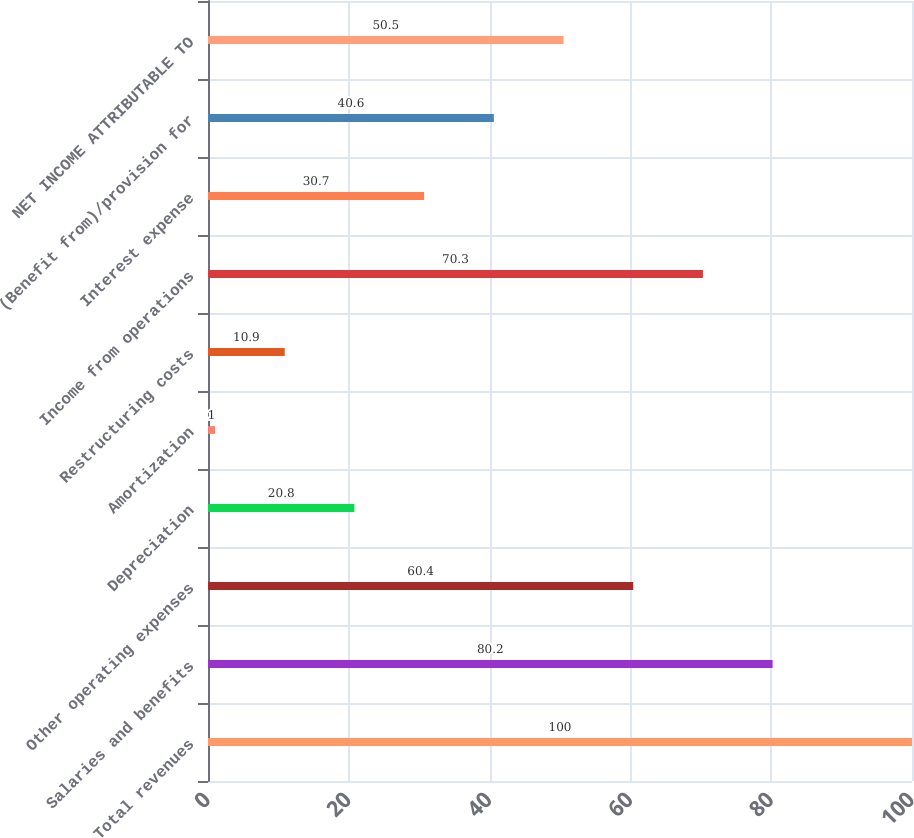Convert chart to OTSL. <chart><loc_0><loc_0><loc_500><loc_500><bar_chart><fcel>Total revenues<fcel>Salaries and benefits<fcel>Other operating expenses<fcel>Depreciation<fcel>Amortization<fcel>Restructuring costs<fcel>Income from operations<fcel>Interest expense<fcel>(Benefit from)/provision for<fcel>NET INCOME ATTRIBUTABLE TO<nl><fcel>100<fcel>80.2<fcel>60.4<fcel>20.8<fcel>1<fcel>10.9<fcel>70.3<fcel>30.7<fcel>40.6<fcel>50.5<nl></chart> 